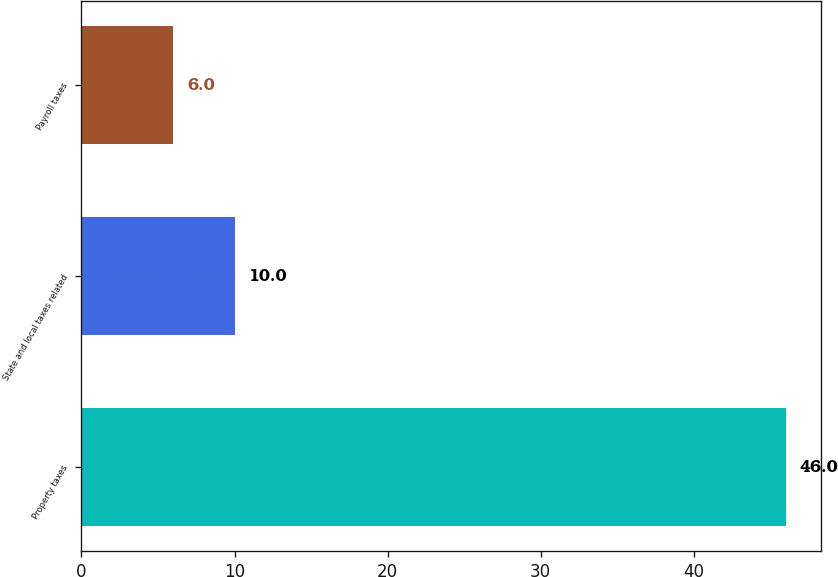<chart> <loc_0><loc_0><loc_500><loc_500><bar_chart><fcel>Property taxes<fcel>State and local taxes related<fcel>Payroll taxes<nl><fcel>46<fcel>10<fcel>6<nl></chart> 